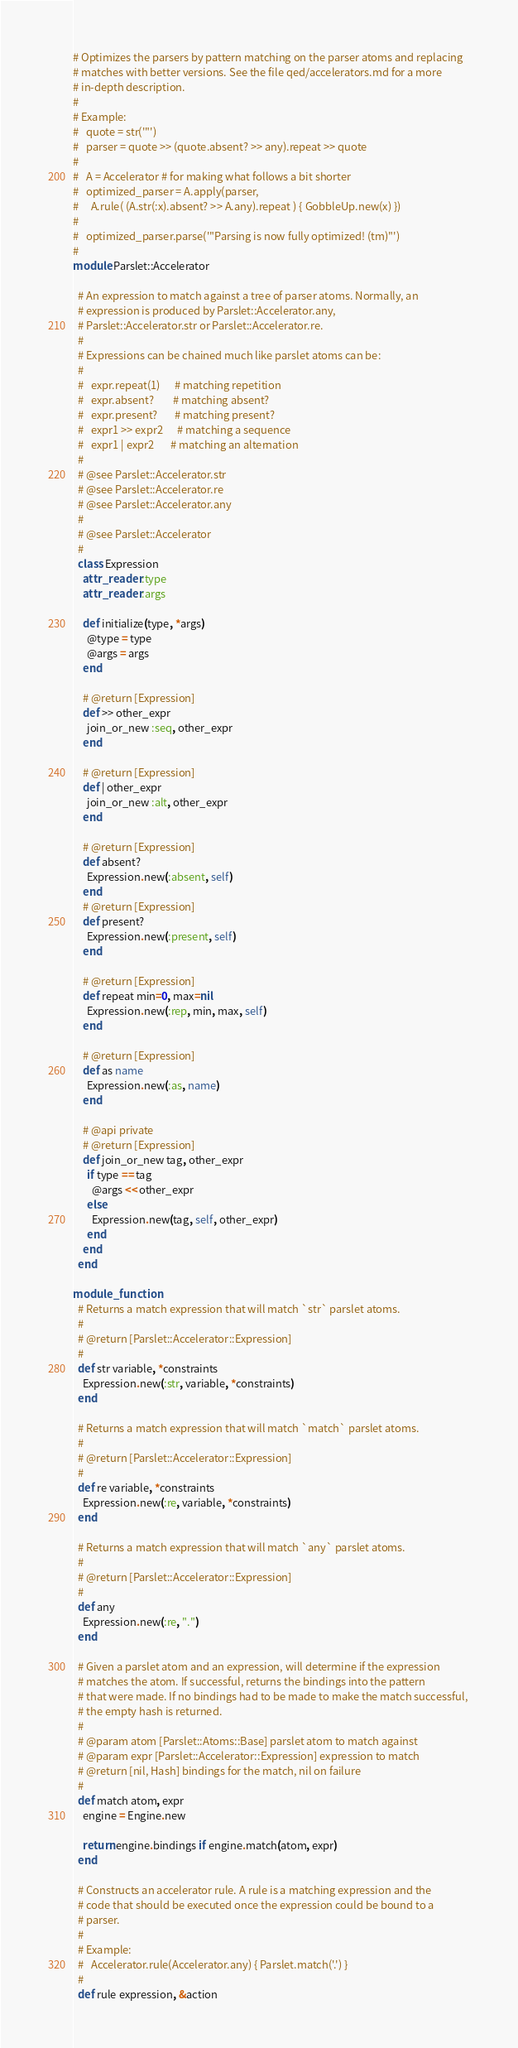Convert code to text. <code><loc_0><loc_0><loc_500><loc_500><_Ruby_>

# Optimizes the parsers by pattern matching on the parser atoms and replacing
# matches with better versions. See the file qed/accelerators.md for a more
# in-depth description.
#
# Example: 
#   quote = str('"')
#   parser = quote >> (quote.absent? >> any).repeat >> quote
#
#   A = Accelerator # for making what follows a bit shorter
#   optimized_parser = A.apply(parser, 
#     A.rule( (A.str(:x).absent? >> A.any).repeat ) { GobbleUp.new(x) })
#
#   optimized_parser.parse('"Parsing is now fully optimized! (tm)"')
#
module Parslet::Accelerator

  # An expression to match against a tree of parser atoms. Normally, an
  # expression is produced by Parslet::Accelerator.any, 
  # Parslet::Accelerator.str or Parslet::Accelerator.re.
  #
  # Expressions can be chained much like parslet atoms can be: 
  #
  #   expr.repeat(1)      # matching repetition
  #   expr.absent?        # matching absent?
  #   expr.present?       # matching present?
  #   expr1 >> expr2      # matching a sequence
  #   expr1 | expr2       # matching an alternation
  # 
  # @see Parslet::Accelerator.str
  # @see Parslet::Accelerator.re
  # @see Parslet::Accelerator.any
  #
  # @see Parslet::Accelerator
  # 
  class Expression
    attr_reader :type
    attr_reader :args

    def initialize(type, *args)
      @type = type
      @args = args
    end

    # @return [Expression]
    def >> other_expr
      join_or_new :seq, other_expr
    end

    # @return [Expression]
    def | other_expr
      join_or_new :alt, other_expr
    end

    # @return [Expression]
    def absent?
      Expression.new(:absent, self)
    end
    # @return [Expression]
    def present?
      Expression.new(:present, self)
    end

    # @return [Expression]
    def repeat min=0, max=nil
      Expression.new(:rep, min, max, self)
    end

    # @return [Expression]
    def as name
      Expression.new(:as, name)
    end

    # @api private
    # @return [Expression]
    def join_or_new tag, other_expr
      if type == tag
        @args << other_expr
      else
        Expression.new(tag, self, other_expr)
      end
    end
  end

module_function 
  # Returns a match expression that will match `str` parslet atoms.
  #
  # @return [Parslet::Accelerator::Expression]
  #
  def str variable, *constraints
    Expression.new(:str, variable, *constraints)
  end

  # Returns a match expression that will match `match` parslet atoms.
  #
  # @return [Parslet::Accelerator::Expression]
  #
  def re variable, *constraints
    Expression.new(:re, variable, *constraints)
  end

  # Returns a match expression that will match `any` parslet atoms.
  #
  # @return [Parslet::Accelerator::Expression]
  #
  def any
    Expression.new(:re, ".")
  end

  # Given a parslet atom and an expression, will determine if the expression
  # matches the atom. If successful, returns the bindings into the pattern
  # that were made. If no bindings had to be made to make the match successful, 
  # the empty hash is returned. 
  #
  # @param atom [Parslet::Atoms::Base] parslet atom to match against
  # @param expr [Parslet::Accelerator::Expression] expression to match
  # @return [nil, Hash] bindings for the match, nil on failure
  #
  def match atom, expr
    engine = Engine.new

    return engine.bindings if engine.match(atom, expr)
  end

  # Constructs an accelerator rule. A rule is a matching expression and the
  # code that should be executed once the expression could be bound to a 
  # parser. 
  #
  # Example: 
  #   Accelerator.rule(Accelerator.any) { Parslet.match('.') }
  #
  def rule expression, &action</code> 